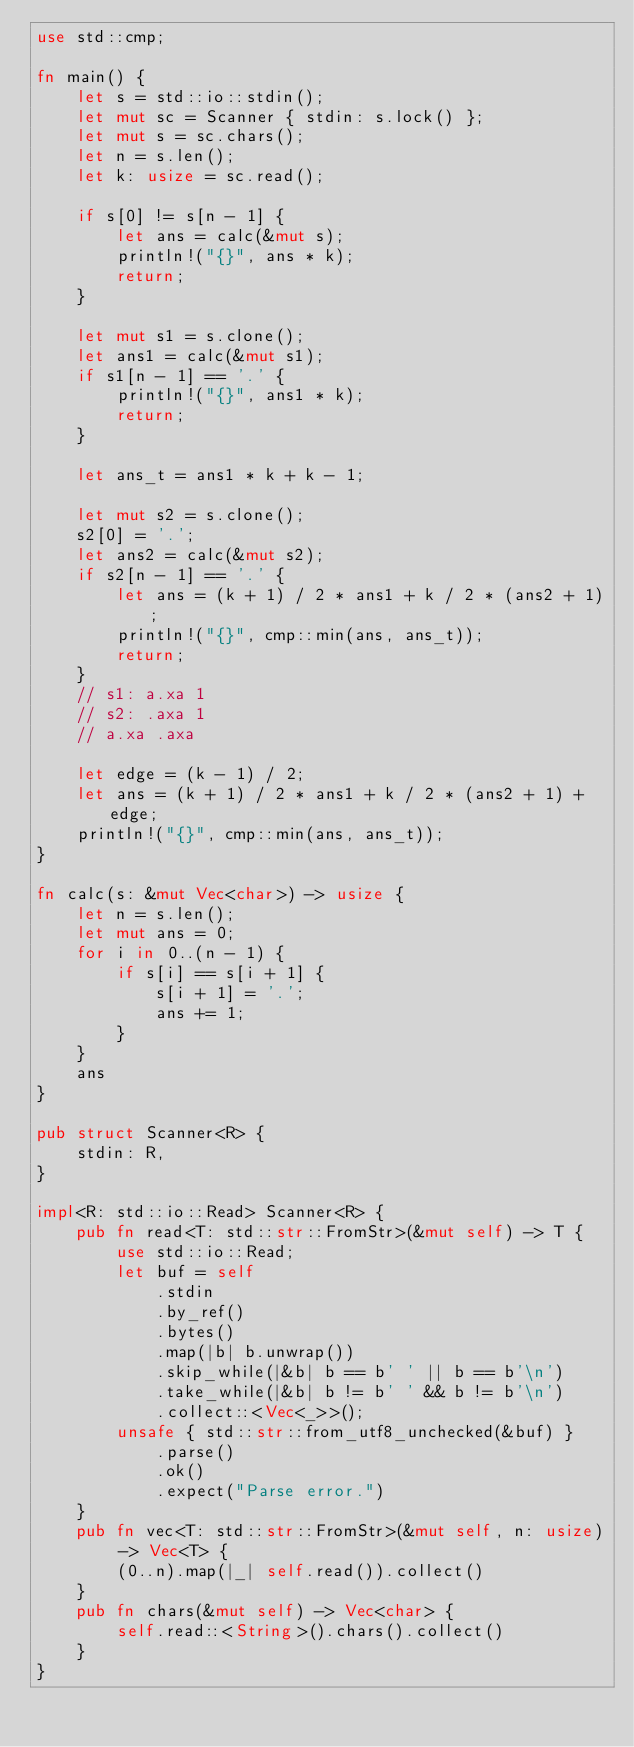<code> <loc_0><loc_0><loc_500><loc_500><_Rust_>use std::cmp;

fn main() {
    let s = std::io::stdin();
    let mut sc = Scanner { stdin: s.lock() };
    let mut s = sc.chars();
    let n = s.len();
    let k: usize = sc.read();

    if s[0] != s[n - 1] {
        let ans = calc(&mut s);
        println!("{}", ans * k);
        return;
    }

    let mut s1 = s.clone();
    let ans1 = calc(&mut s1);
    if s1[n - 1] == '.' {
        println!("{}", ans1 * k);
        return;
    }

    let ans_t = ans1 * k + k - 1;

    let mut s2 = s.clone();
    s2[0] = '.';
    let ans2 = calc(&mut s2);
    if s2[n - 1] == '.' {
        let ans = (k + 1) / 2 * ans1 + k / 2 * (ans2 + 1);
        println!("{}", cmp::min(ans, ans_t));
        return;
    }
    // s1: a.xa 1
    // s2: .axa 1
    // a.xa .axa

    let edge = (k - 1) / 2;
    let ans = (k + 1) / 2 * ans1 + k / 2 * (ans2 + 1) + edge;
    println!("{}", cmp::min(ans, ans_t));
}

fn calc(s: &mut Vec<char>) -> usize {
    let n = s.len();
    let mut ans = 0;
    for i in 0..(n - 1) {
        if s[i] == s[i + 1] {
            s[i + 1] = '.';
            ans += 1;
        }
    }
    ans
}

pub struct Scanner<R> {
    stdin: R,
}

impl<R: std::io::Read> Scanner<R> {
    pub fn read<T: std::str::FromStr>(&mut self) -> T {
        use std::io::Read;
        let buf = self
            .stdin
            .by_ref()
            .bytes()
            .map(|b| b.unwrap())
            .skip_while(|&b| b == b' ' || b == b'\n')
            .take_while(|&b| b != b' ' && b != b'\n')
            .collect::<Vec<_>>();
        unsafe { std::str::from_utf8_unchecked(&buf) }
            .parse()
            .ok()
            .expect("Parse error.")
    }
    pub fn vec<T: std::str::FromStr>(&mut self, n: usize) -> Vec<T> {
        (0..n).map(|_| self.read()).collect()
    }
    pub fn chars(&mut self) -> Vec<char> {
        self.read::<String>().chars().collect()
    }
}
</code> 